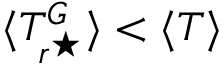Convert formula to latex. <formula><loc_0><loc_0><loc_500><loc_500>\langle T _ { r ^ { ^ { * } } } ^ { G } \rangle < \langle T \rangle</formula> 